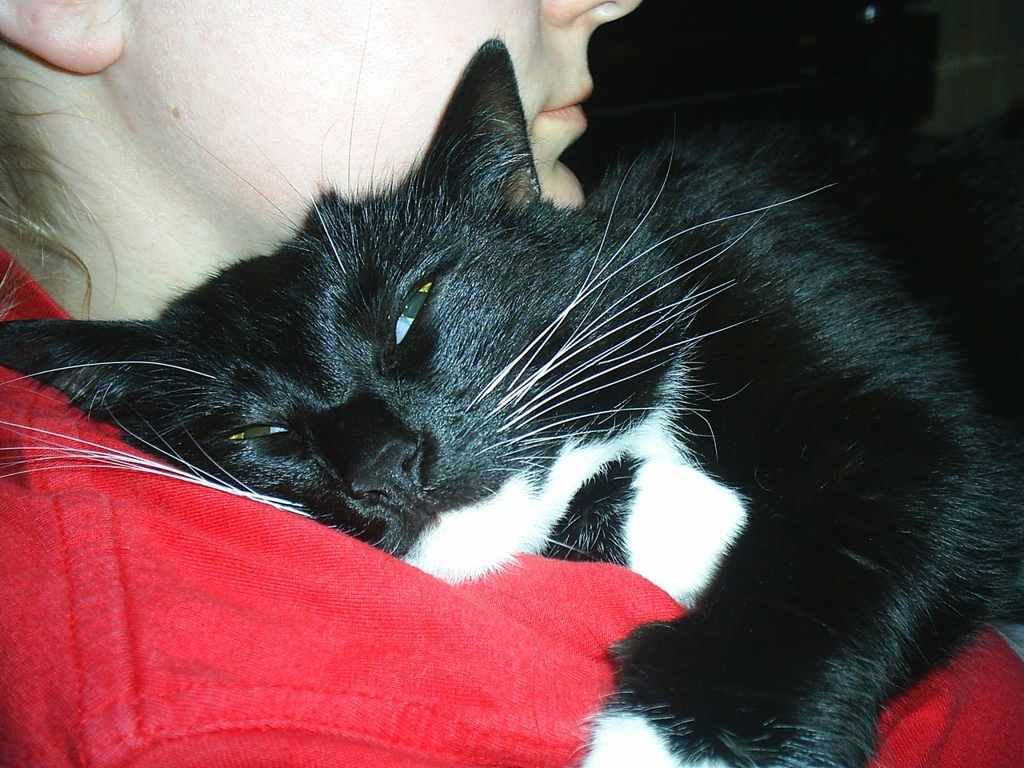Describe the colors and patterns you see in this image. The striking image features a predominantly black cat with captivating white patches, including a distinguished white mustache. The cat's fur has a healthy sheen, displaying shades of deep onyx that contrast with the pure white. The cat is resting against a vivid red fabric, presumably the person's shirt, which draws the viewer's eye and makes a bold backdrop for the cat's coloring. 